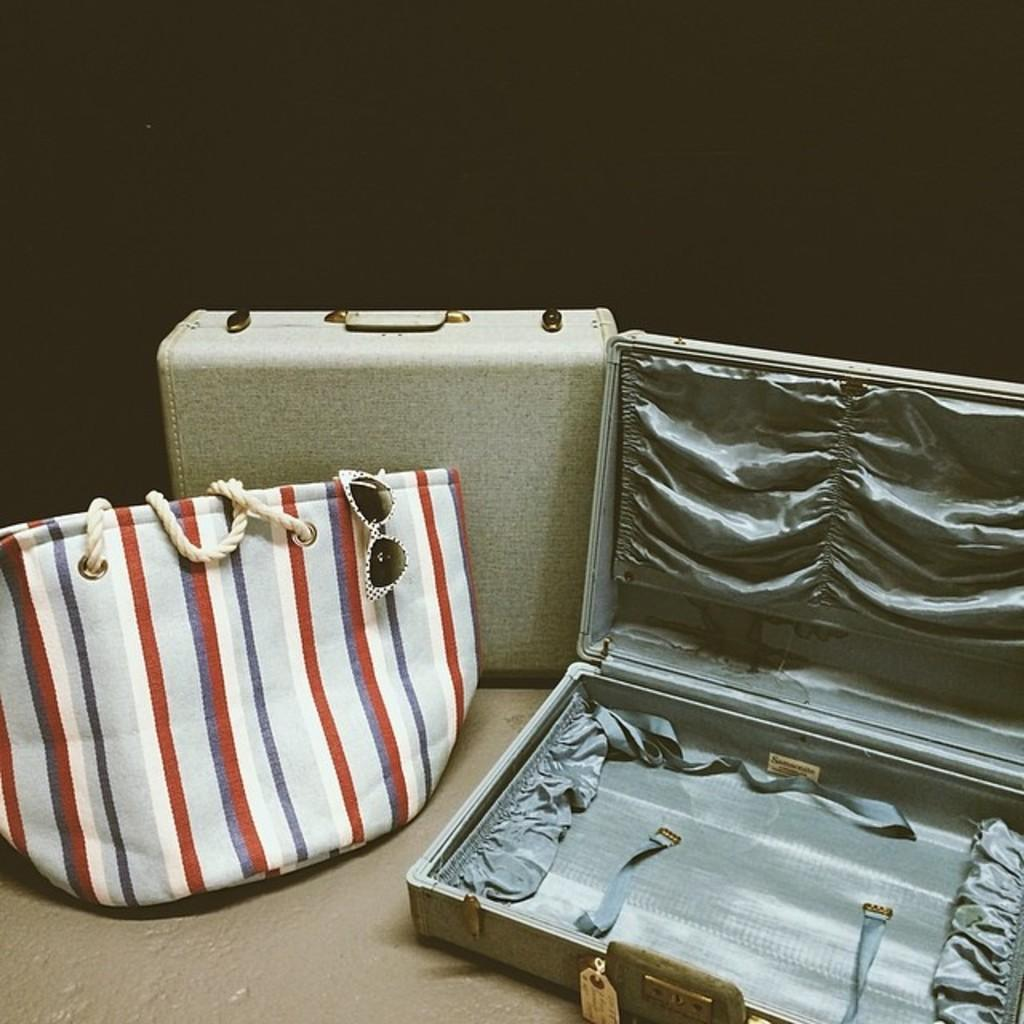What type of objects can be seen in the image? There are bags and glasses in the image. Can you describe the bags in the image? Unfortunately, the facts provided do not give any details about the bags, so we cannot describe them further. What can be said about the glasses in the image? Similarly, the facts provided do not give any details about the glasses, so we cannot describe them further. Where is the throne located in the image? There is no throne present in the image. What type of plane can be seen flying in the image? There is no plane present in the image. 